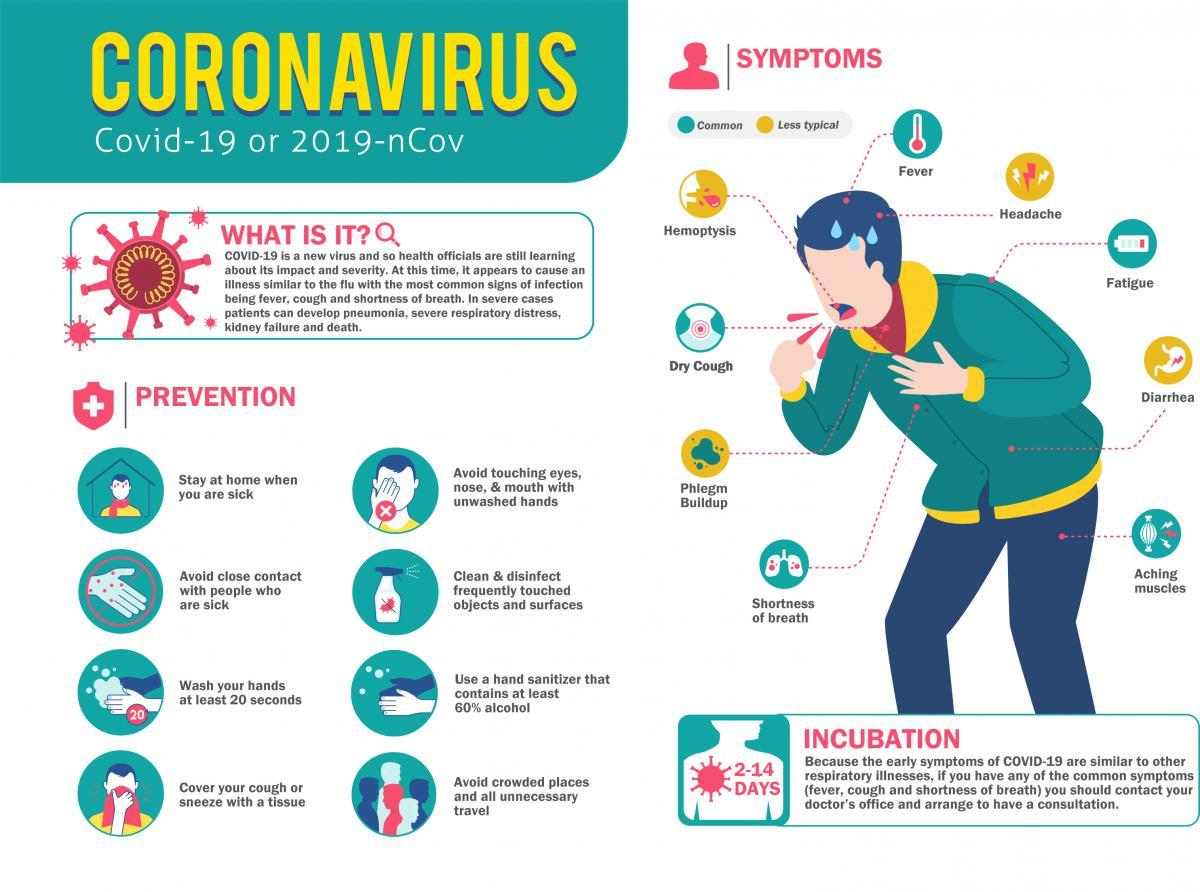Point out several critical features in this image. The incubation period is typically 2-14 days. The cloth used to cover the face is red. It is advisable to remain at home when one is afflicted with illness. The spray bottle indicates the need to regularly clean and disinfect frequently touched objects and surfaces to maintain a clean and hygienic environment. Dry cough and fatigue are common symptoms. 